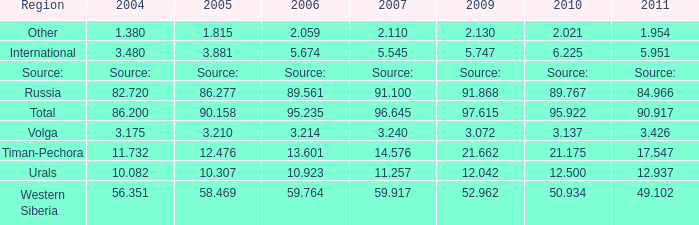What is the 2007 Lukoil oil prodroduction when in 2010 oil production 3.137 million tonnes? 3.24. 